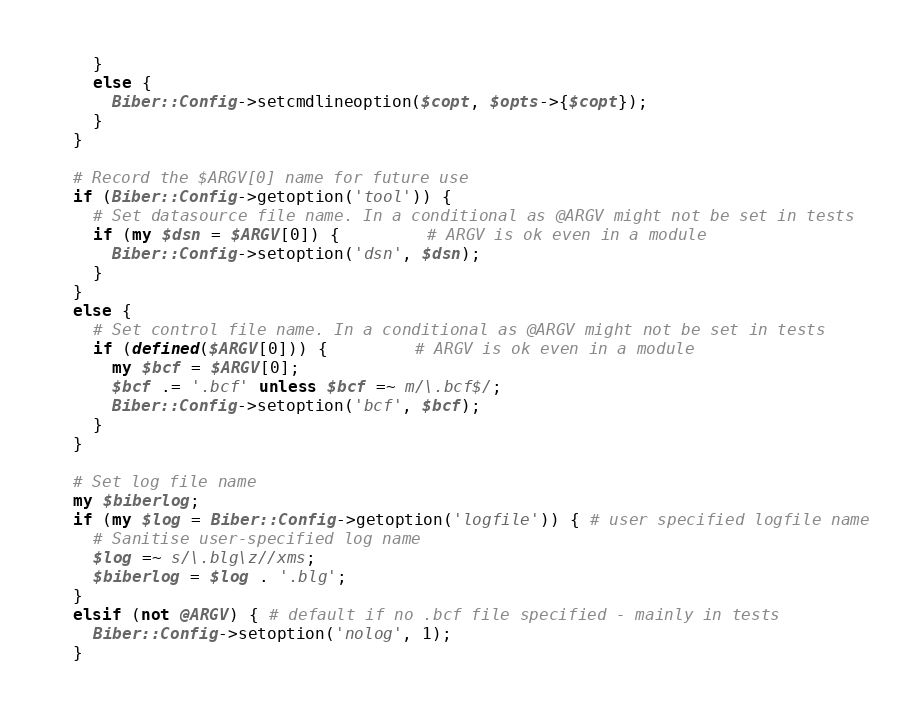<code> <loc_0><loc_0><loc_500><loc_500><_Perl_>    }
    else {
      Biber::Config->setcmdlineoption($copt, $opts->{$copt});
    }
  }

  # Record the $ARGV[0] name for future use
  if (Biber::Config->getoption('tool')) {
    # Set datasource file name. In a conditional as @ARGV might not be set in tests
    if (my $dsn = $ARGV[0]) {         # ARGV is ok even in a module
      Biber::Config->setoption('dsn', $dsn);
    }
  }
  else {
    # Set control file name. In a conditional as @ARGV might not be set in tests
    if (defined($ARGV[0])) {         # ARGV is ok even in a module
      my $bcf = $ARGV[0];
      $bcf .= '.bcf' unless $bcf =~ m/\.bcf$/;
      Biber::Config->setoption('bcf', $bcf);
    }
  }

  # Set log file name
  my $biberlog;
  if (my $log = Biber::Config->getoption('logfile')) { # user specified logfile name
    # Sanitise user-specified log name
    $log =~ s/\.blg\z//xms;
    $biberlog = $log . '.blg';
  }
  elsif (not @ARGV) { # default if no .bcf file specified - mainly in tests
    Biber::Config->setoption('nolog', 1);
  }</code> 